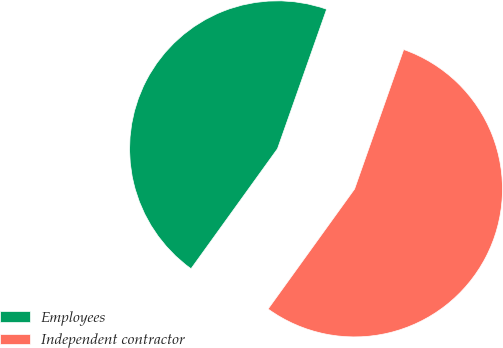Convert chart to OTSL. <chart><loc_0><loc_0><loc_500><loc_500><pie_chart><fcel>Employees<fcel>Independent contractor<nl><fcel>45.45%<fcel>54.55%<nl></chart> 